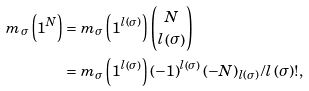<formula> <loc_0><loc_0><loc_500><loc_500>m _ { \sigma } \left ( 1 ^ { N } \right ) & = m _ { \sigma } \left ( 1 ^ { l \left ( \sigma \right ) } \right ) \binom { N } { l \left ( \sigma \right ) } \\ & = m _ { \sigma } \left ( 1 ^ { l \left ( \sigma \right ) } \right ) \left ( - 1 \right ) ^ { l \left ( \sigma \right ) } \left ( - N \right ) _ { l \left ( \sigma \right ) } / l \left ( \sigma \right ) ! ,</formula> 